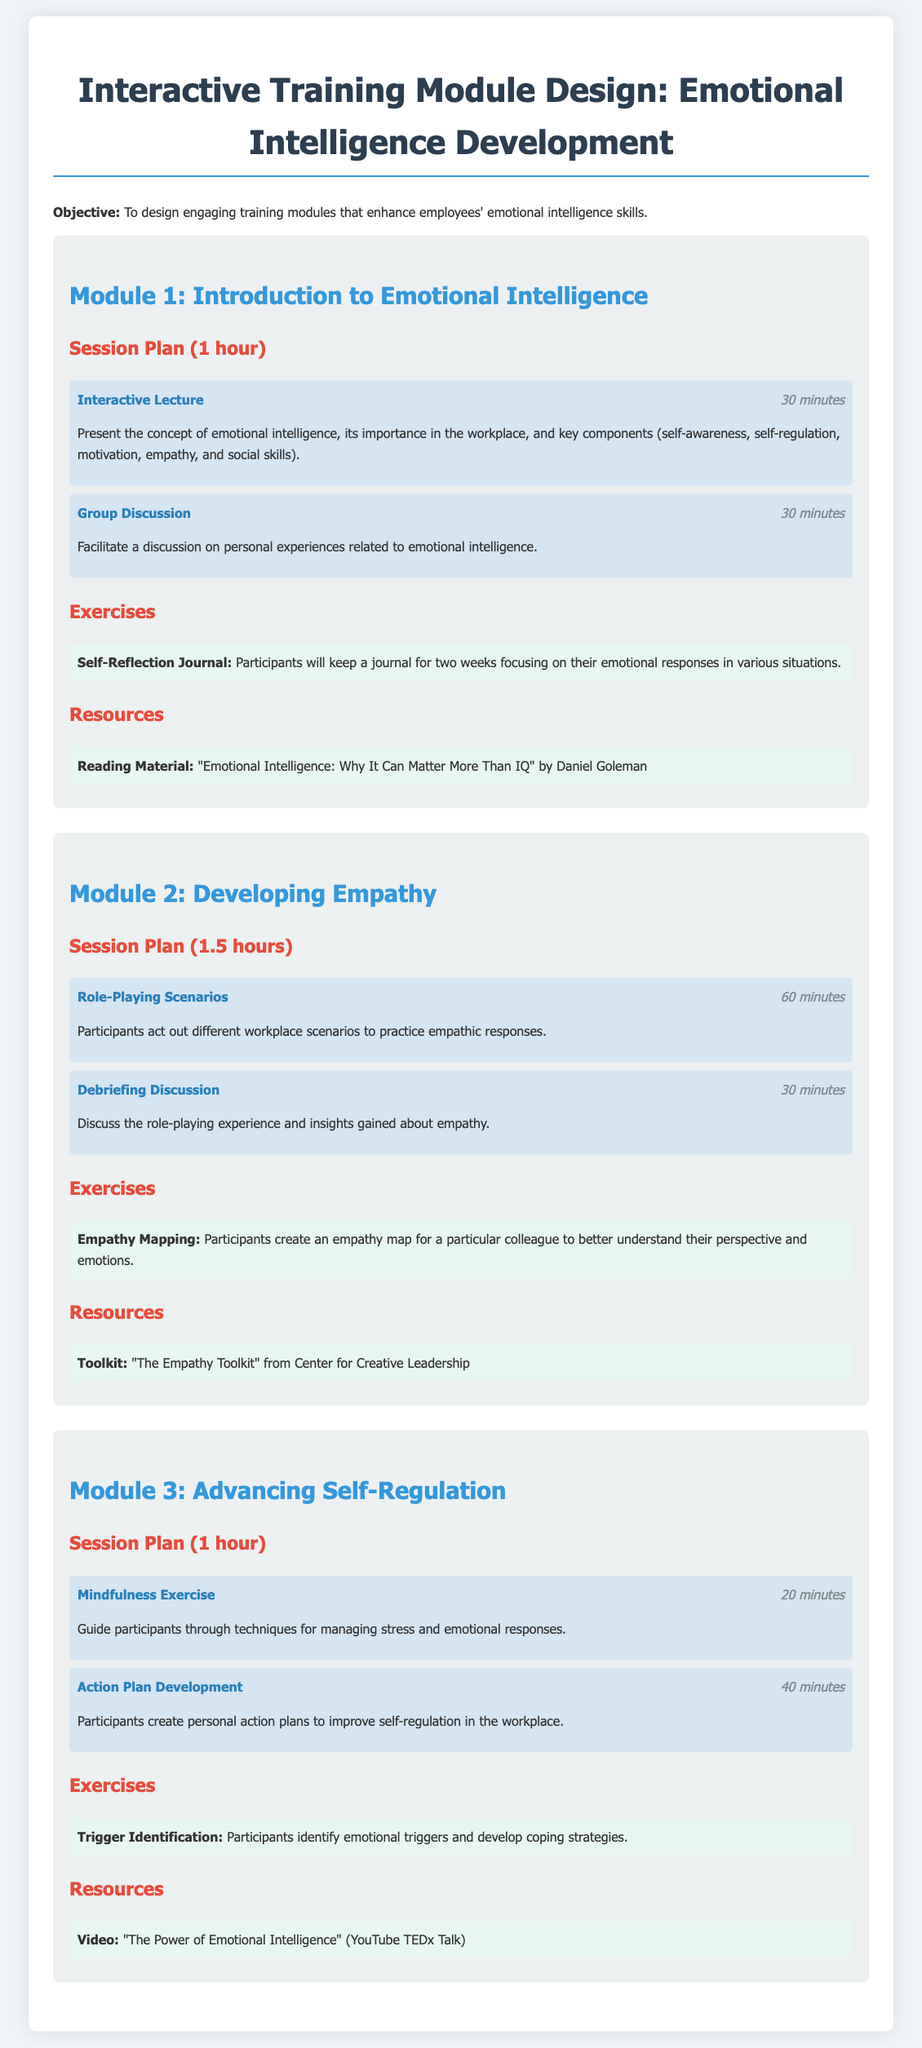What is the objective of the training module? The objective is stated at the beginning of the document as enhancing emotional intelligence skills.
Answer: Enhance emotional intelligence skills How long is Module 2: Developing Empathy? The duration of Module 2 is specified in the session plan section.
Answer: 1.5 hours What activity is included in Module 1 for 30 minutes? The specific activity for this duration can be found in the session plan of Module 1.
Answer: Group Discussion Which resource is mentioned for Module 3? The resource for Module 3 is clearly listed under the resources section.
Answer: Video: "The Power of Emotional Intelligence" (YouTube TEDx Talk) What is the main exercise in Module 2? The main exercise details are mentioned in the exercises section of Module 2.
Answer: Empathy Mapping 